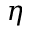<formula> <loc_0><loc_0><loc_500><loc_500>\eta</formula> 